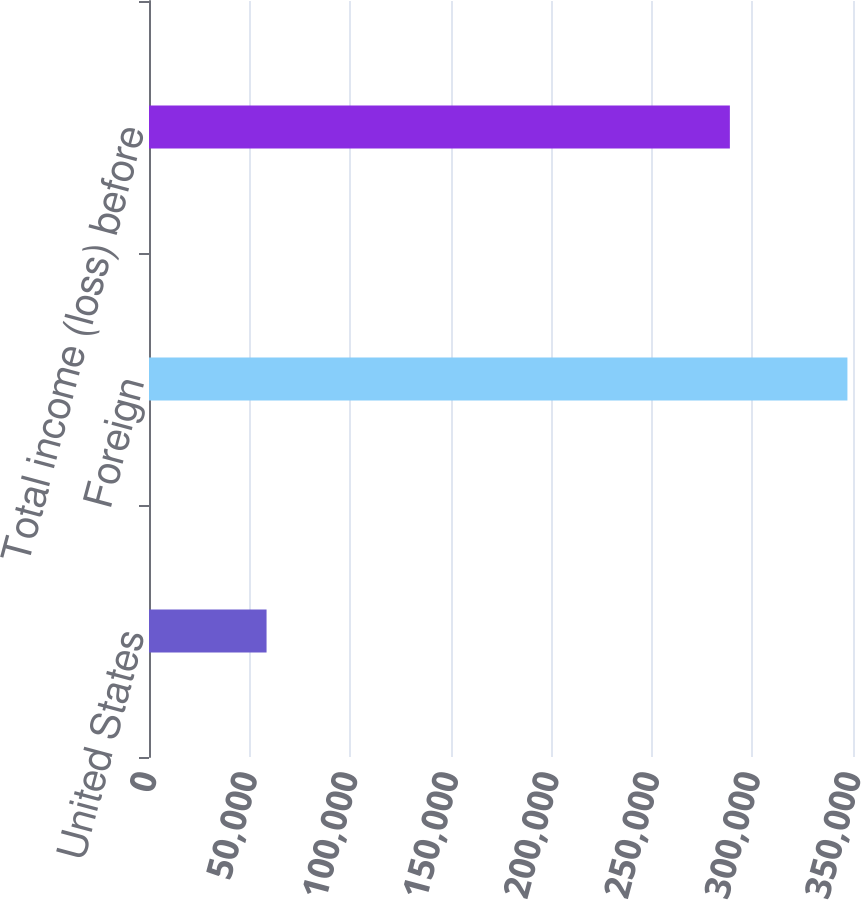Convert chart. <chart><loc_0><loc_0><loc_500><loc_500><bar_chart><fcel>United States<fcel>Foreign<fcel>Total income (loss) before<nl><fcel>58445<fcel>347230<fcel>288785<nl></chart> 